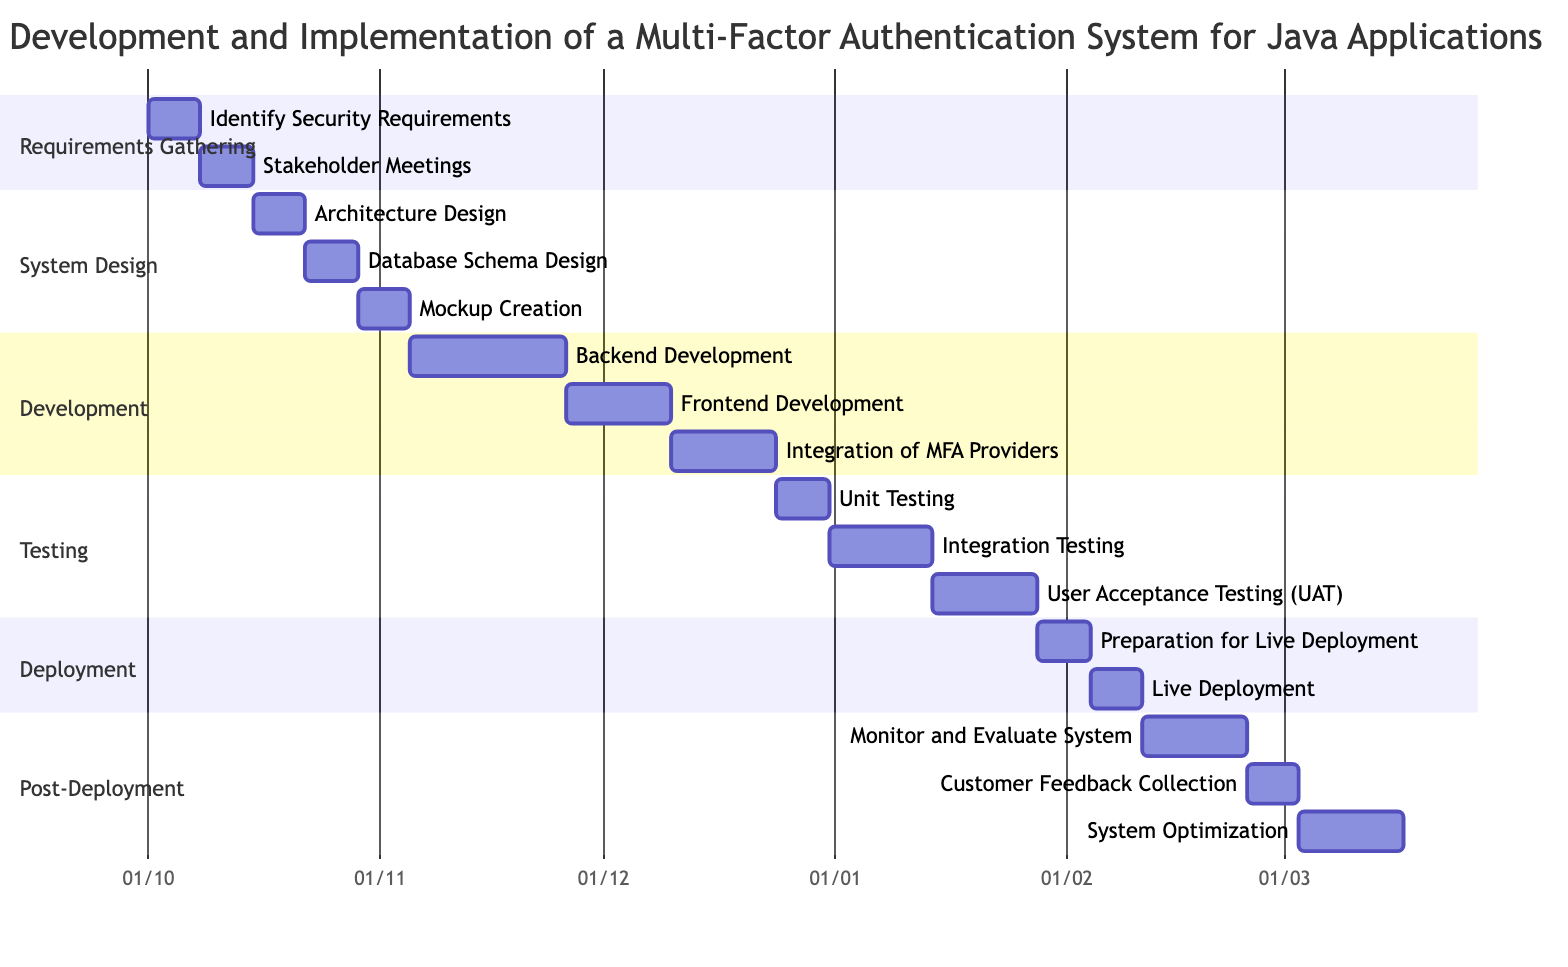What are the start and end dates for the "User Acceptance Testing (UAT)" milestone? The "User Acceptance Testing (UAT)" milestone starts on January 14, 2024, and ends on January 27, 2024.
Answer: January 14, 2024 - January 27, 2024 How long does the "Frontend Development" phase last? "Frontend Development" starts on November 26, 2023, and ends on December 9, 2023, which is a total of 14 days.
Answer: 14 days Which phase is the longest in terms of duration? "Development" has three milestones that last a total of 49 days (21 days for Backend Development, 14 days for Frontend Development, and 14 days for Integration of MFA Providers).
Answer: Development What is the sequence of milestones from "Requirements Gathering" to "Testing"? The milestones are: Identify Security Requirements, Stakeholder Meetings, Unit Testing, Integration Testing, User Acceptance Testing (UAT).
Answer: Identify Security Requirements, Stakeholder Meetings, Unit Testing, Integration Testing, User Acceptance Testing (UAT) When does the "Live Deployment" milestone occur? The "Live Deployment" milestone starts on February 4, 2024, and ends on February 10, 2024.
Answer: February 4, 2024 - February 10, 2024 How many milestones are there in the "Post-Deployment" phase? There are three milestones in the "Post-Deployment" phase: Monitor and Evaluate System, Customer Feedback Collection, and System Optimization.
Answer: 3 Which milestone follows "Database Schema Design"? The "Mockup Creation" milestone follows "Database Schema Design", occurring after it on October 29, 2023.
Answer: Mockup Creation What is the total duration of the "Testing" phase? The "Testing" phase consists of three milestones: Unit Testing (7 days), Integration Testing (14 days), and User Acceptance Testing (14 days), totaling 35 days.
Answer: 35 days What is the start date of the "Monitoring and Evaluating System" milestone? The "Monitor and Evaluate System" milestone starts on February 11, 2024.
Answer: February 11, 2024 